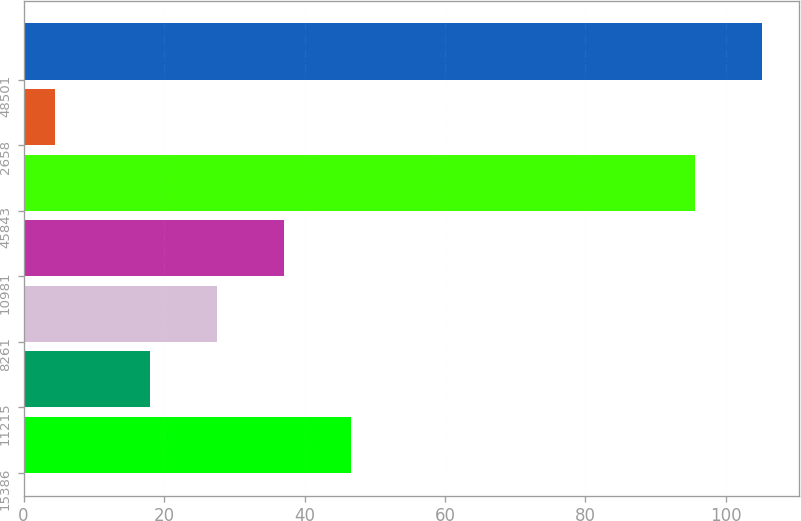<chart> <loc_0><loc_0><loc_500><loc_500><bar_chart><fcel>15386<fcel>11215<fcel>8261<fcel>10981<fcel>45843<fcel>2658<fcel>48501<nl><fcel>46.68<fcel>18<fcel>27.56<fcel>37.12<fcel>95.6<fcel>4.4<fcel>105.16<nl></chart> 